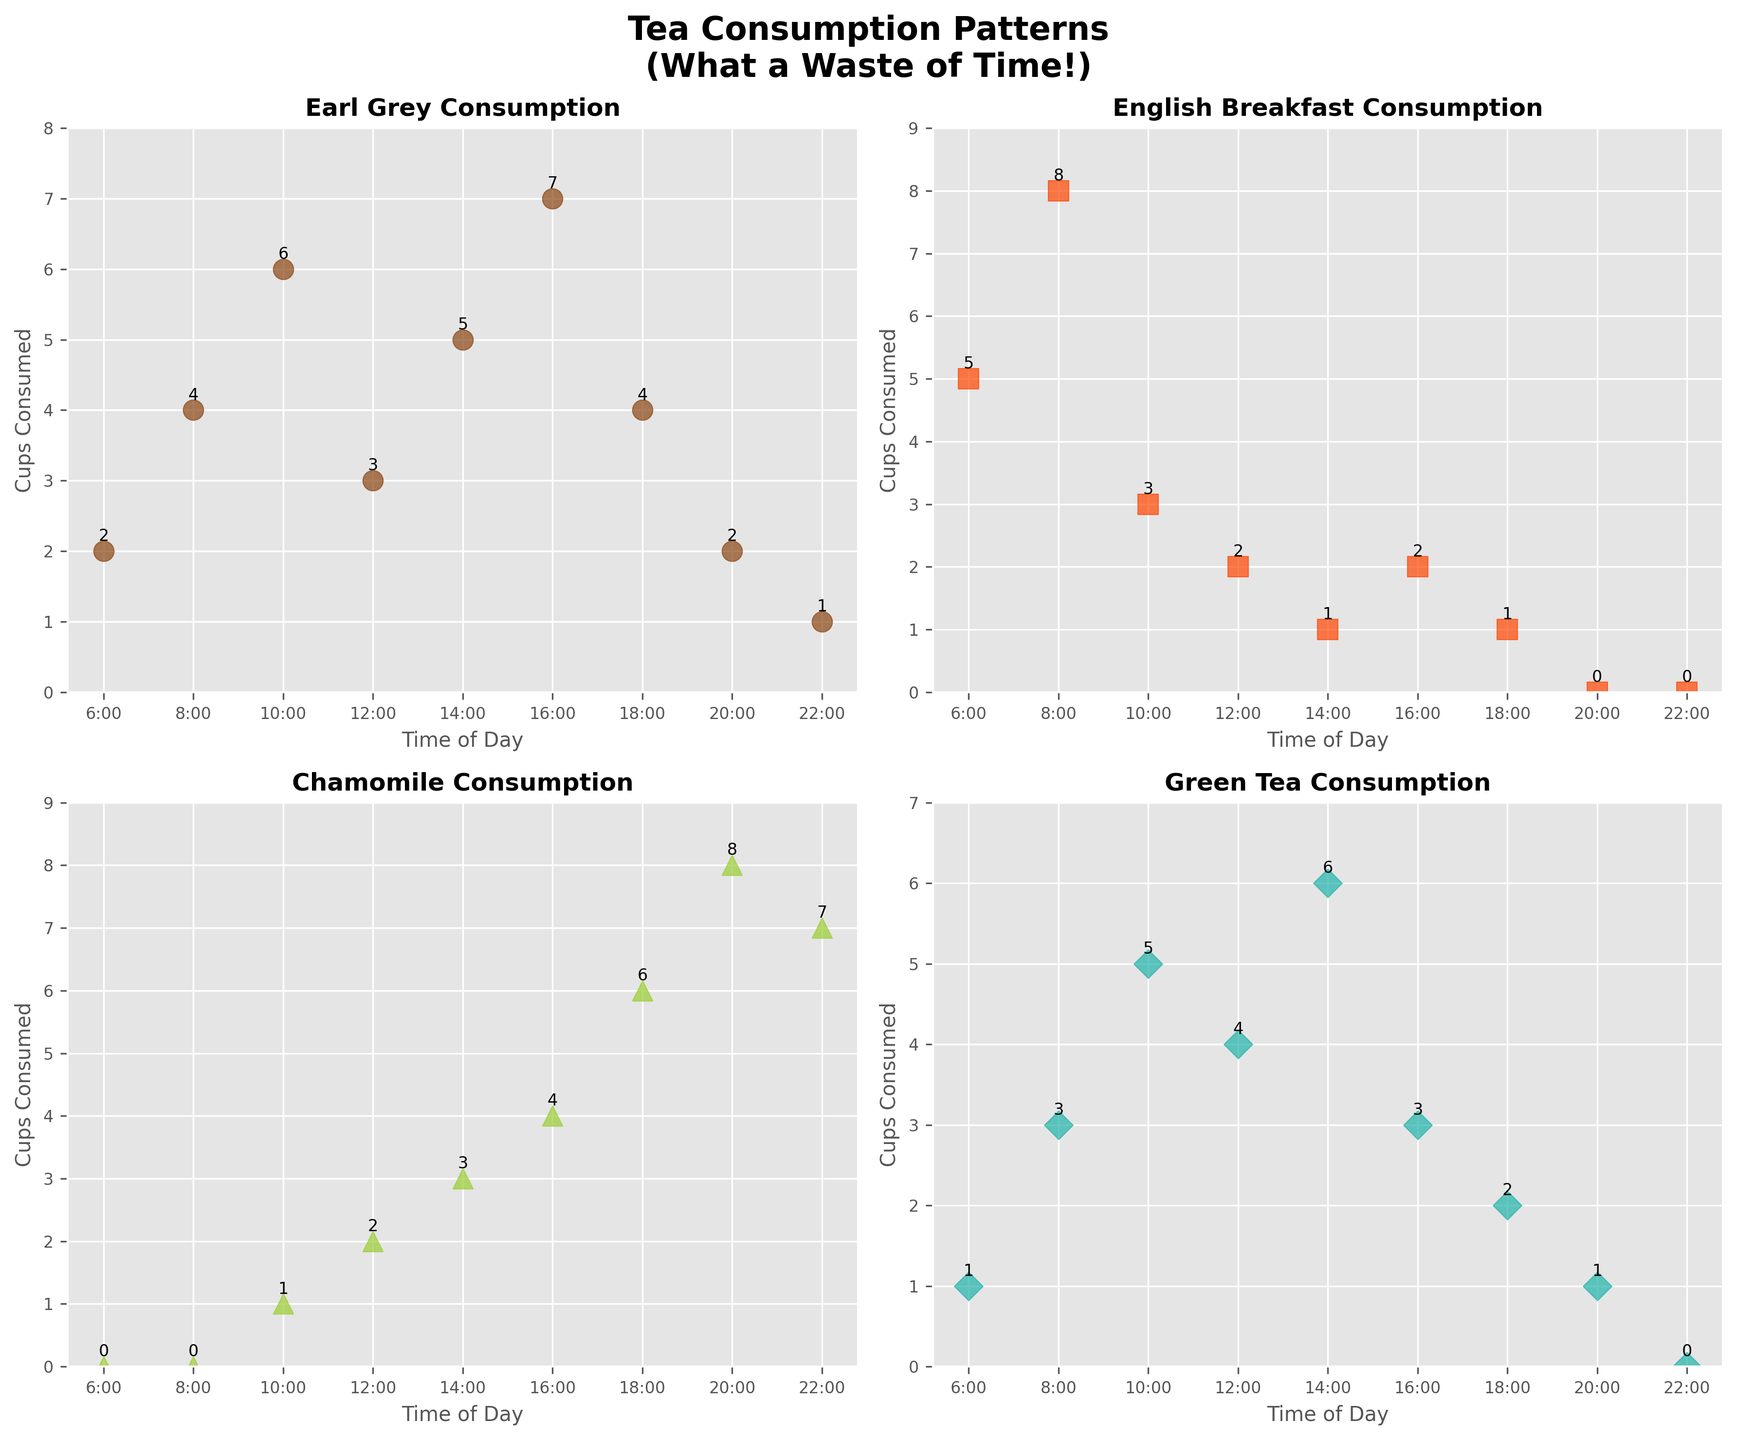What is the title of the chart? The title is located at the top center of the figure. It reads "Tea Consumption Patterns" with a smaller subtitle in parentheses saying, "What a Waste of Time!".
Answer: Tea Consumption Patterns (What a Waste of Time!) What is the tea type with the highest consumption at 10:00? To find this, look at the points plotted on the x-axis corresponding to 10:00 for each subplot. Chamomile has the lowest consumption (1 cup), while Green Tea has the highest consumption (5 cups). The highest point is found in the Green Tea subplot.
Answer: Green Tea How many cups of Chamomile tea are consumed at 20:00? Find the subplot for Chamomile tea. The data point corresponding to 20:00 shows the number 8 next to the point.
Answer: 8 During which hour is Earl Grey's consumption the highest? Check the Earl Grey subplot and identify the highest point. This point is labeled at 16:00 with 7 cups.
Answer: 16:00 Which tea has the lowest overall consumption at 14:00? At 14:00, check each subplot and compare the values. Earl Grey has 5 cups, English Breakfast has 1 cup, Chamomile has 3 cups, and Green Tea has 6 cups. English Breakfast has the lowest with 1 cup.
Answer: English Breakfast How does the consumption of Green Tea at 6:00 compare to its consumption at 22:00? Check the Green Tea subplot for the data points at 6:00 and 22:00. At 6:00, it's 1 cup and at 22:00, it's 0 cups. 1 cup is greater than 0 cups.
Answer: 6:00 is higher than 22:00 What is the average number of cups consumed in total across all four tea types at 16:00? Sum the consumption at 16:00 for all tea types: Earl Grey (7), English Breakfast (2), Chamomile (4), Green Tea (3). Sum is 7+2+4+3 = 16. Average is 16/4 = 4.
Answer: 4 How many types of tea have their highest consumption between 6:00 and 10:00? For each tea type, check whether the max number falls within 6:00 to 10:00. Earl Grey at 16:00 (no), English Breakfast at 8:00 (yes), Chamomile at 20:00 (no), Green Tea at 14:00 (no). Therefore, only one tea type fits this criterion.
Answer: 1 Which tea has the most consistent consumption throughout the day? Look for the subplot that has the least fluctuation in the y-axis values. Earl Grey and Green Tea have more variations; English Breakfast shows low values but still has fluctuations. Chamomile shows a steady increase and then decreases slightly.
Answer: English Breakfast What time of day is the peak consumption of Chamomile tea, and what might this suggest about when people prefer to drink it? The Chamomile subplot shows the highest consumption at 20:00 and 22:00 with 8 and 7 cups, respectively. This suggests that people prefer Chamomile tea in the evening.
Answer: 20:00 and 22:00, evening preference 